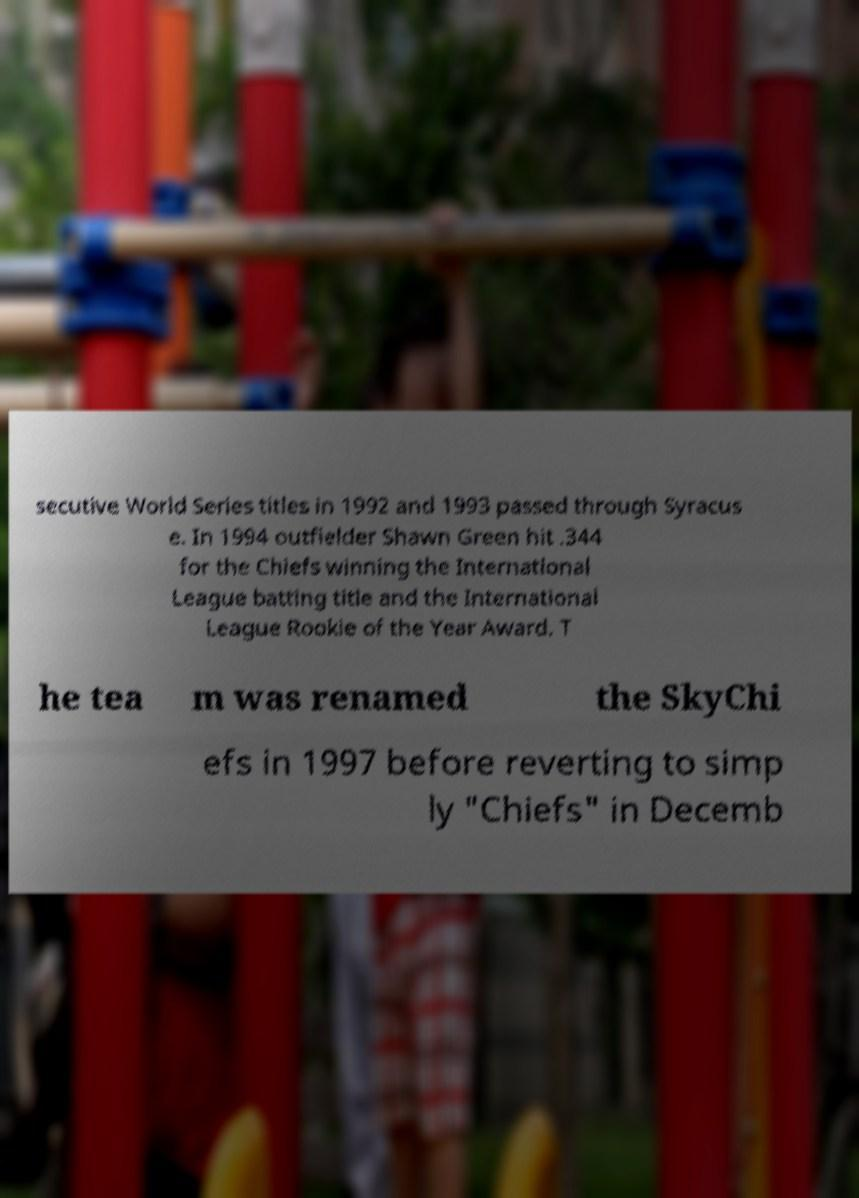I need the written content from this picture converted into text. Can you do that? secutive World Series titles in 1992 and 1993 passed through Syracus e. In 1994 outfielder Shawn Green hit .344 for the Chiefs winning the International League batting title and the International League Rookie of the Year Award. T he tea m was renamed the SkyChi efs in 1997 before reverting to simp ly "Chiefs" in Decemb 